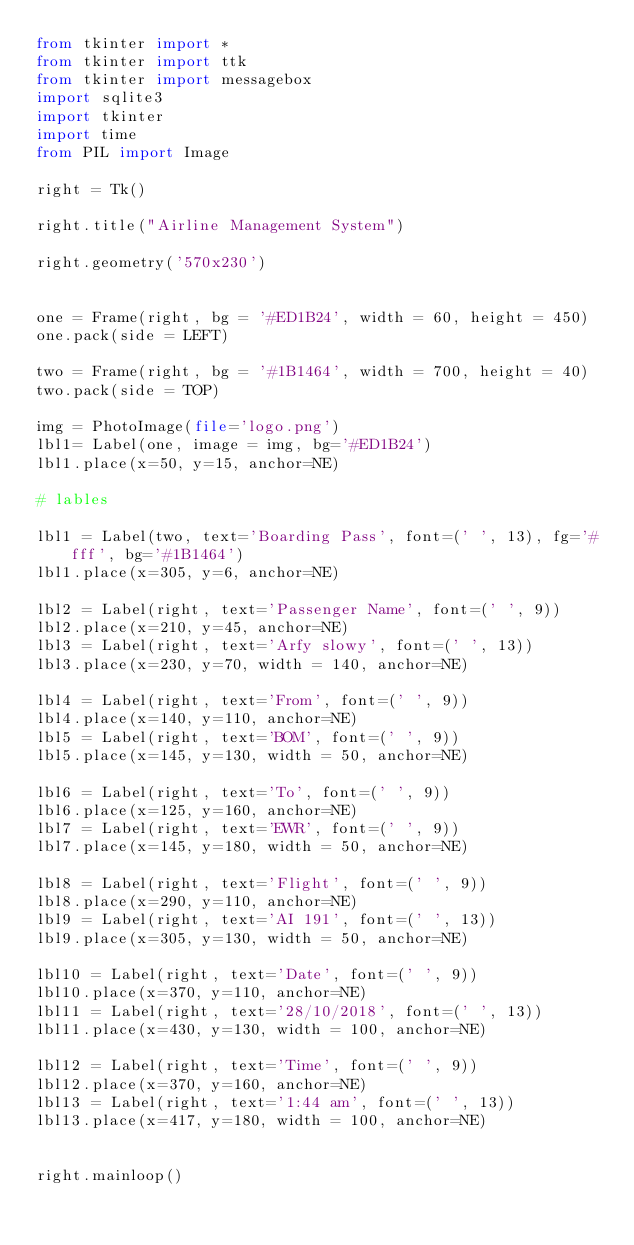<code> <loc_0><loc_0><loc_500><loc_500><_Python_>from tkinter import *
from tkinter import ttk
from tkinter import messagebox
import sqlite3
import tkinter
import time
from PIL import Image
 
right = Tk()
 
right.title("Airline Management System")

right.geometry('570x230')

       
one = Frame(right, bg = '#ED1B24', width = 60, height = 450)
one.pack(side = LEFT)

two = Frame(right, bg = '#1B1464', width = 700, height = 40)
two.pack(side = TOP)

img = PhotoImage(file='logo.png')
lbl1= Label(one, image = img, bg='#ED1B24')
lbl1.place(x=50, y=15, anchor=NE)

# lables

lbl1 = Label(two, text='Boarding Pass', font=(' ', 13), fg='#fff', bg='#1B1464')
lbl1.place(x=305, y=6, anchor=NE)

lbl2 = Label(right, text='Passenger Name', font=(' ', 9))
lbl2.place(x=210, y=45, anchor=NE)
lbl3 = Label(right, text='Arfy slowy', font=(' ', 13))
lbl3.place(x=230, y=70, width = 140, anchor=NE)

lbl4 = Label(right, text='From', font=(' ', 9))
lbl4.place(x=140, y=110, anchor=NE)
lbl5 = Label(right, text='BOM', font=(' ', 9))
lbl5.place(x=145, y=130, width = 50, anchor=NE)

lbl6 = Label(right, text='To', font=(' ', 9))
lbl6.place(x=125, y=160, anchor=NE)
lbl7 = Label(right, text='EWR', font=(' ', 9))
lbl7.place(x=145, y=180, width = 50, anchor=NE)

lbl8 = Label(right, text='Flight', font=(' ', 9))
lbl8.place(x=290, y=110, anchor=NE)
lbl9 = Label(right, text='AI 191', font=(' ', 13))
lbl9.place(x=305, y=130, width = 50, anchor=NE)

lbl10 = Label(right, text='Date', font=(' ', 9))
lbl10.place(x=370, y=110, anchor=NE)
lbl11 = Label(right, text='28/10/2018', font=(' ', 13))
lbl11.place(x=430, y=130, width = 100, anchor=NE)

lbl12 = Label(right, text='Time', font=(' ', 9))
lbl12.place(x=370, y=160, anchor=NE)
lbl13 = Label(right, text='1:44 am', font=(' ', 13))
lbl13.place(x=417, y=180, width = 100, anchor=NE)


right.mainloop()</code> 